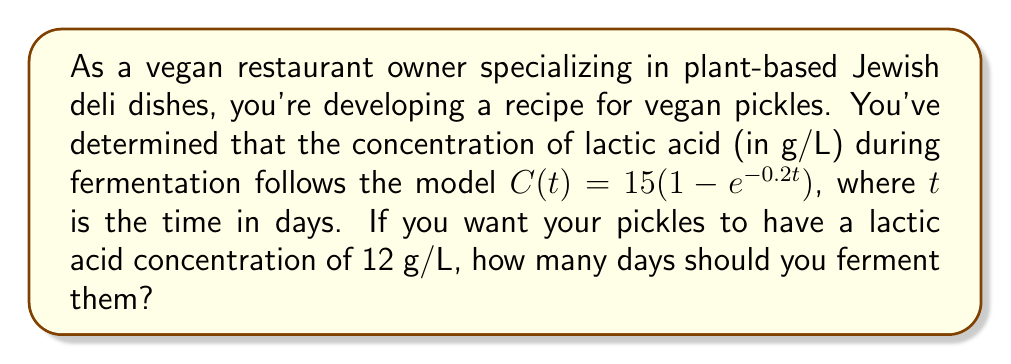Can you answer this question? To solve this problem, we need to use the given exponential model and find the time $t$ when the concentration $C(t)$ reaches 12 g/L. Let's approach this step-by-step:

1) We start with the equation:
   $C(t) = 15(1 - e^{-0.2t})$

2) We want to find $t$ when $C(t) = 12$, so we set up the equation:
   $12 = 15(1 - e^{-0.2t})$

3) Divide both sides by 15:
   $\frac{12}{15} = 1 - e^{-0.2t}$

4) Simplify:
   $0.8 = 1 - e^{-0.2t}$

5) Subtract both sides from 1:
   $0.2 = e^{-0.2t}$

6) Take the natural log of both sides:
   $\ln(0.2) = -0.2t$

7) Divide both sides by -0.2:
   $\frac{\ln(0.2)}{-0.2} = t$

8) Calculate:
   $t \approx 8.047$ days

Therefore, you should ferment the pickles for approximately 8.05 days to achieve a lactic acid concentration of 12 g/L.
Answer: 8.05 days 